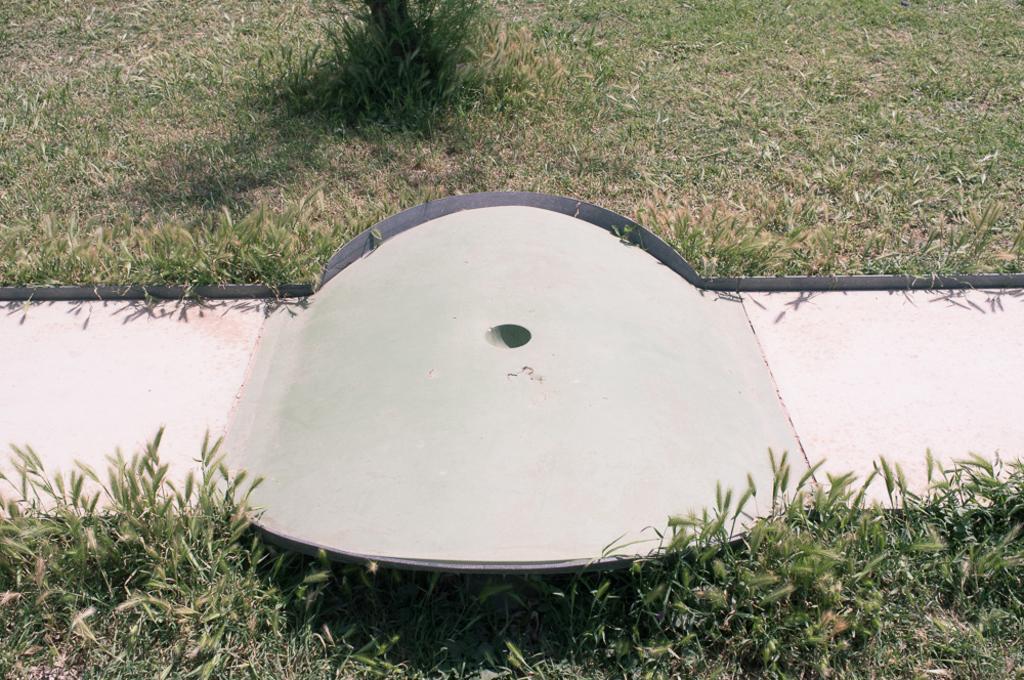Please provide a concise description of this image. In this picture we can see the ground covered with grass & in the middle we can see a path with a ramp. 